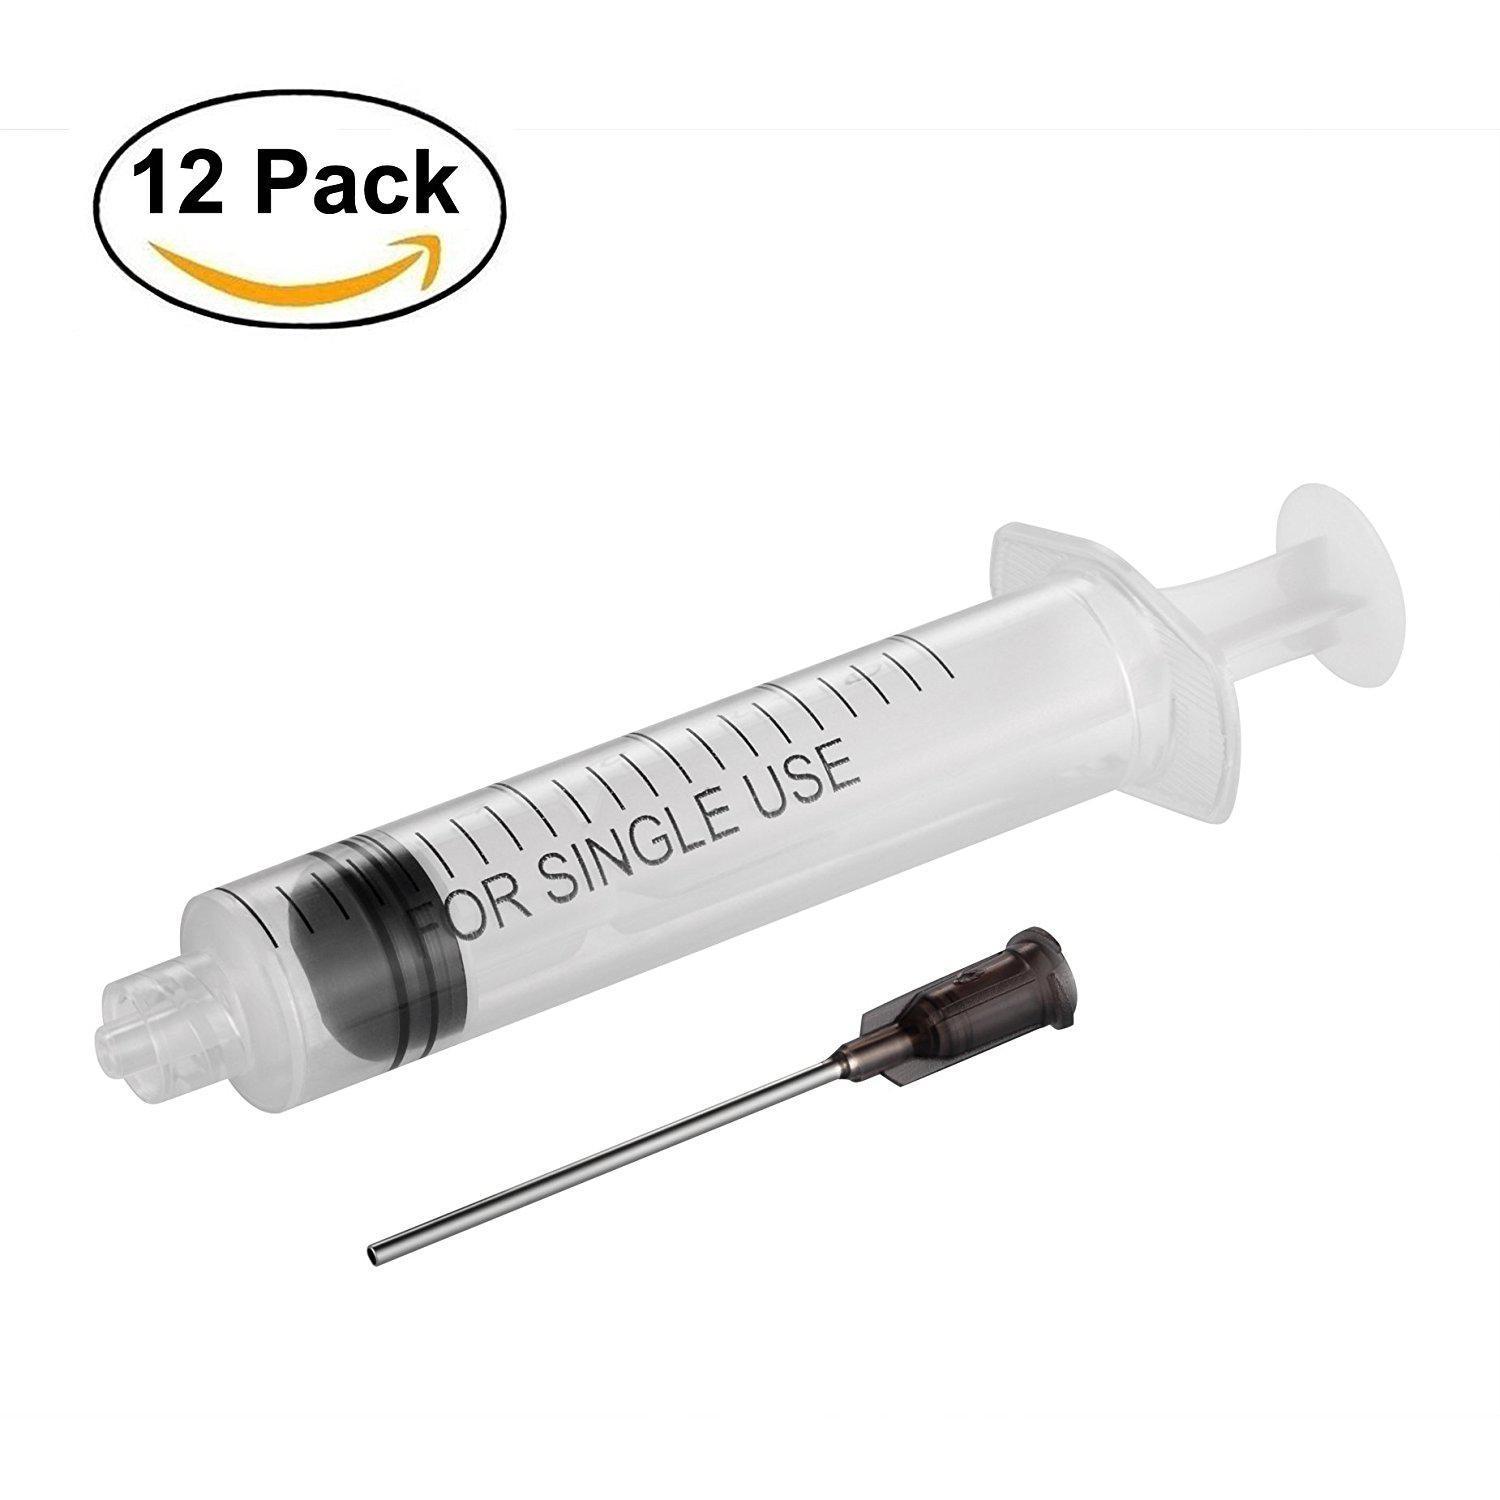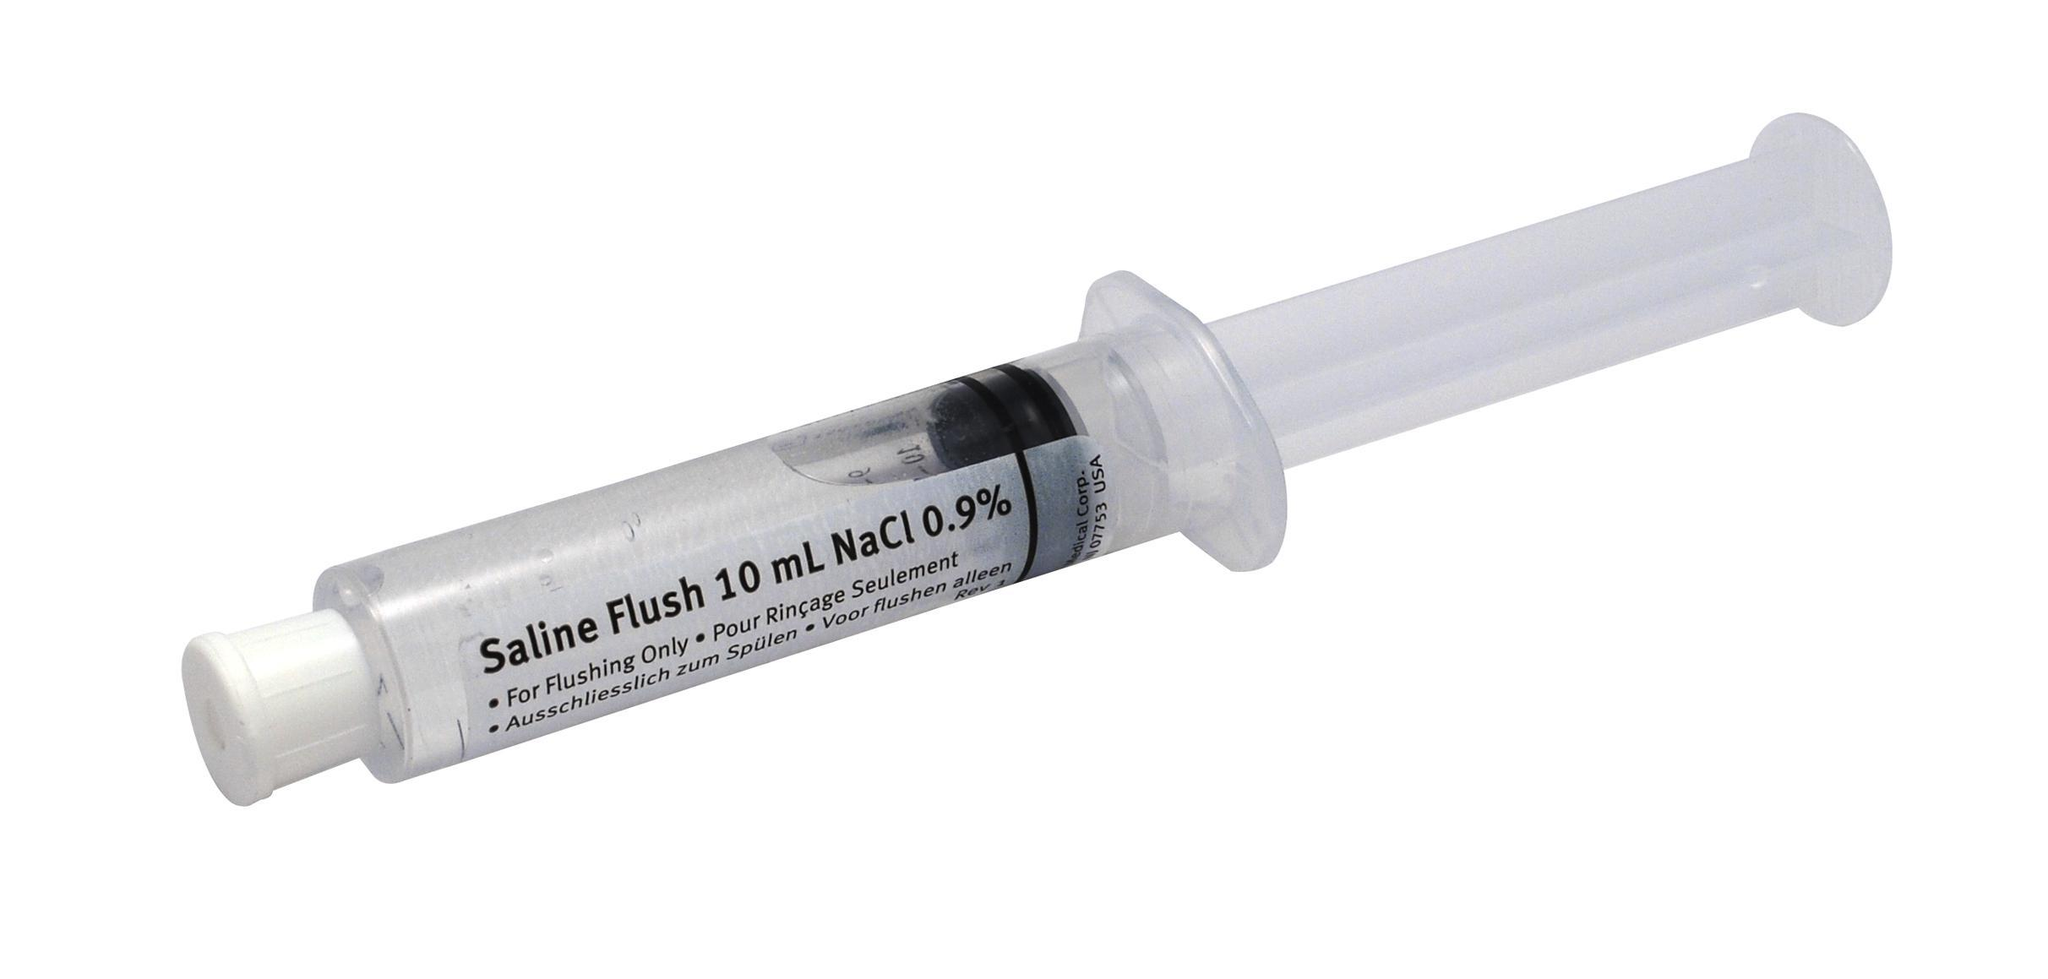The first image is the image on the left, the second image is the image on the right. Given the left and right images, does the statement "Both images show syringes with needles attached." hold true? Answer yes or no. No. The first image is the image on the left, the second image is the image on the right. Assess this claim about the two images: "Both syringes do not have the needle attached.". Correct or not? Answer yes or no. Yes. 